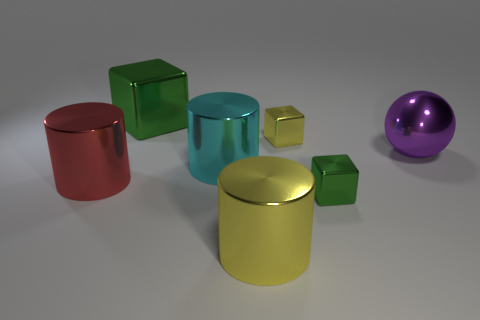What can you infer about the texture of these objects? The objects in the image appear to have a smooth, reflective texture, indicative of polished metal surfaces. The way the light reflects off each object suggests that they are likely to be quite smooth to the touch, with no visible imperfections or roughness. Do the reflections tell us anything about the surroundings? While the reflections on the surfaces are not clearly defined, they hint at a neutral environment with diffuse lighting. The reflections are not detailed enough to convey a specific setting, but they do suggest that the objects are placed in an open space with a light source that is neither too bright nor too direct. 